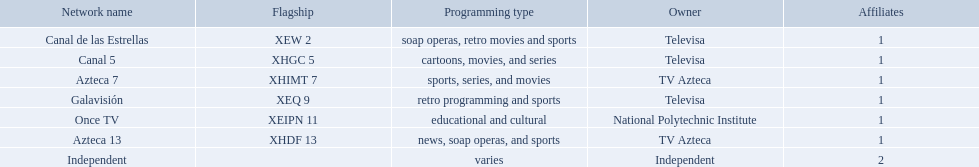What stations show sports? Soap operas, retro movies and sports, retro programming and sports, news, soap operas, and sports. What of these is not affiliated with televisa? Azteca 7. Who are the owners of the stations listed here? Televisa, Televisa, TV Azteca, Televisa, National Polytechnic Institute, TV Azteca, Independent. What is the one station owned by national polytechnic institute? Once TV. Which possessor has sole ownership of one network? National Polytechnic Institute, Independent. Of those, what is the network designation? Once TV, Independent. Of those, which programming kind is educational and cultural? Once TV. Who is the owner with just one network to their name? National Polytechnic Institute, Independent. What is the name of this particular network? Once TV, Independent. Which of these networks is dedicated to cultural and educational programming? Once TV. Can you identify the owners of these listed stations? Televisa, Televisa, TV Azteca, Televisa, National Polytechnic Institute, TV Azteca, Independent. Which particular station is owned by the national polytechnic institute? Once TV. 